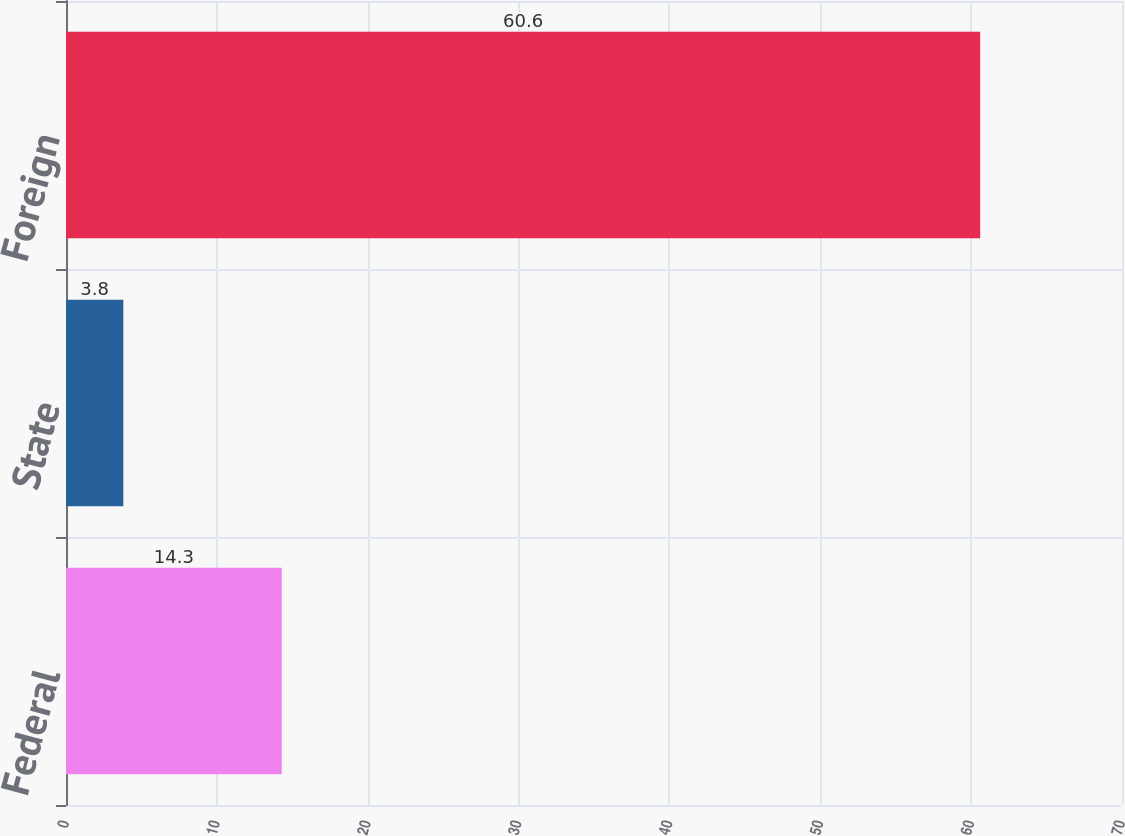Convert chart to OTSL. <chart><loc_0><loc_0><loc_500><loc_500><bar_chart><fcel>Federal<fcel>State<fcel>Foreign<nl><fcel>14.3<fcel>3.8<fcel>60.6<nl></chart> 